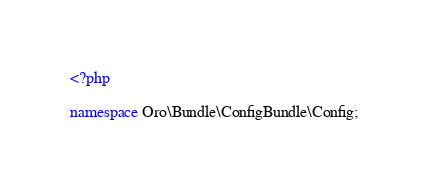<code> <loc_0><loc_0><loc_500><loc_500><_PHP_><?php

namespace Oro\Bundle\ConfigBundle\Config;
</code> 